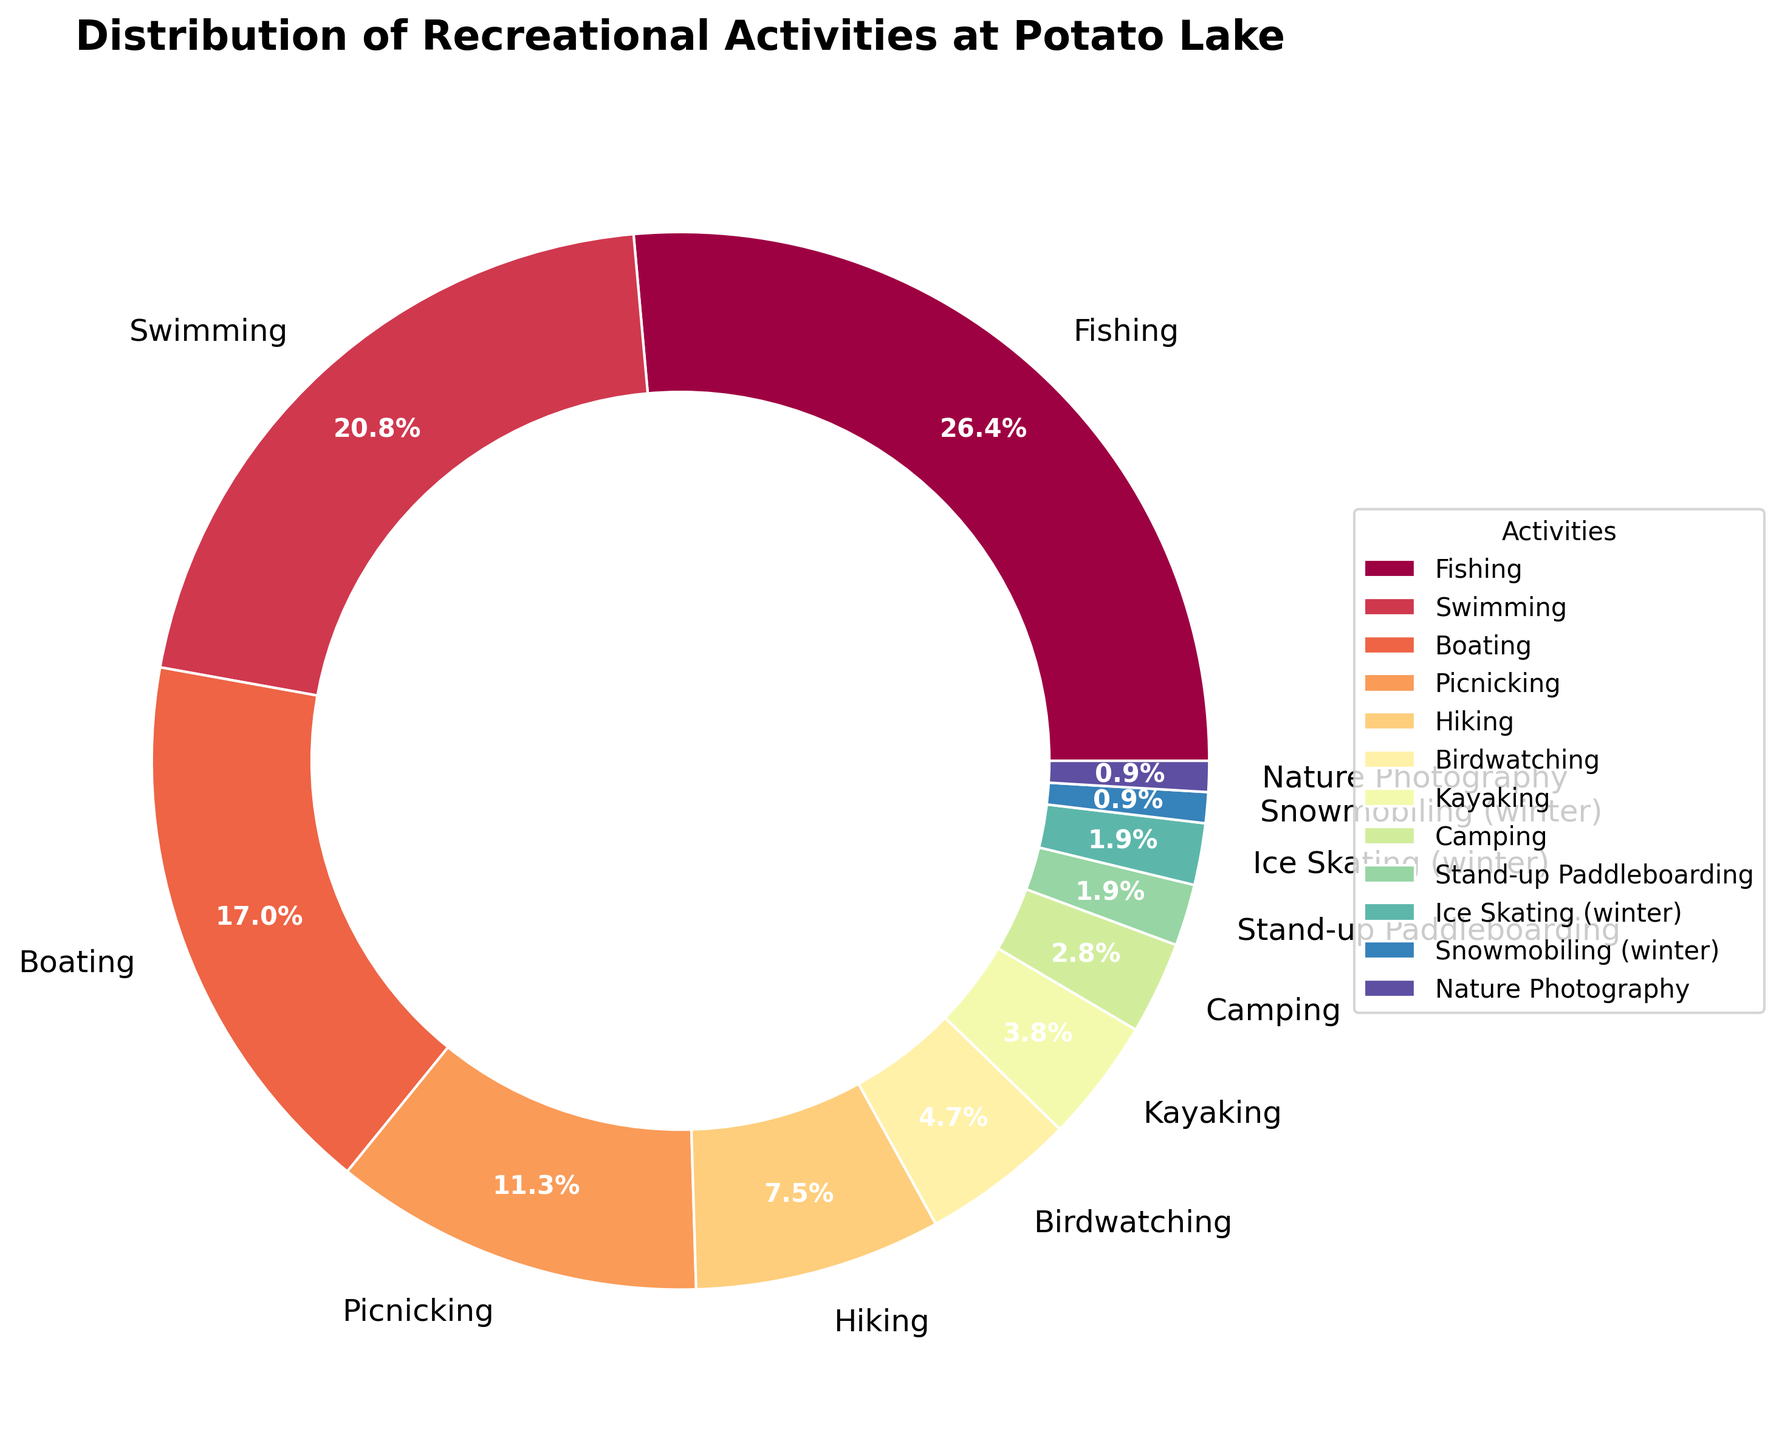What activity is most popular at Potato Lake? The figure shows the distribution of activities with their corresponding percentages. The activity with the highest percentage is the most popular.
Answer: Fishing How much more popular is Fishing compared to Hiking? Look at the percentages for Fishing and Hiking, then subtract the percentage of Hiking from the percentage of Fishing.
Answer: 20% Which activities have the same percentage participation during winter? According to the figure, Ice Skating and Snowmobiling each account for 2% and 1%, respectively. Neither share the same percentage, though they are the only winter activities listed.
Answer: None What is the second least popular activity at Potato Lake? Identify the activity with the second smallest percentage from the chart. Snowmobiling has 1%, so the second least popular activity is Camping with 3%.
Answer: Camping What is the combined percentage of Boating, Kayaking, and Stand-up Paddleboarding? Sum the percentages given for Boating (18%), Kayaking (4%), and Stand-up Paddleboarding (2%).
Answer: 24% How does Picnicking compare with Birdwatching in terms of popularity? Compare the percentages of Picnicking (12%) and Birdwatching (5%). Picnicking has a higher percentage than Birdwatching.
Answer: Picnicking is more popular What fraction of activities has a participation rate of 4% or less? Count the activities with 4% or less: Kayaking (4%), Camping (3%), Stand-up Paddleboarding (2%), Ice Skating (2%), Snowmobiling (1%), and Nature Photography (1%). There are 6 out of 12 activities. The fraction is 6/12.
Answer: 1/2 What percentage of people prefer water-based activities (Fishing, Swimming, Boating, Kayaking, Stand-up Paddleboarding)? Add the percentages of Fishing (28%), Swimming (22%), Boating (18%), Kayaking (4%), and Stand-up Paddleboarding (2%).
Answer: 74% How many activities are less popular than Picnicking? Compare the percentage of Picnicking (12%) with other activities and count those with lower percentages. Birdwatching, Kayaking, Camping, Stand-up Paddleboarding, Ice Skating, Snowmobiling, and Nature Photography each have lower percentages, totaling 7 activities.
Answer: 7 Which two activities together equal about the popularity of Swimming? Look for two activities whose percentages sum to approximately 22%. In this case, Picnicking (12%) and Hiking (8%) together equal 20%, which is close to Swimming's 22%.
Answer: Picnicking and Hiking 